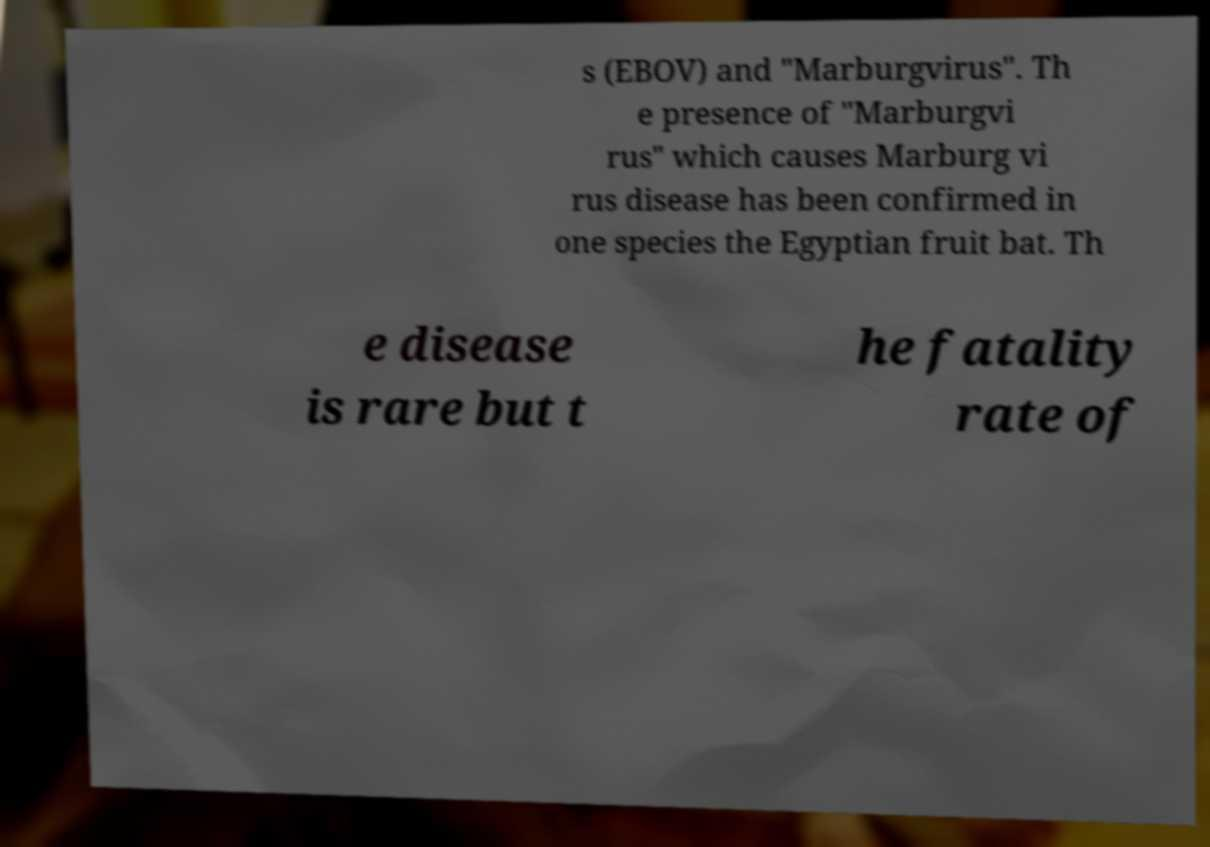What messages or text are displayed in this image? I need them in a readable, typed format. s (EBOV) and "Marburgvirus". Th e presence of "Marburgvi rus" which causes Marburg vi rus disease has been confirmed in one species the Egyptian fruit bat. Th e disease is rare but t he fatality rate of 